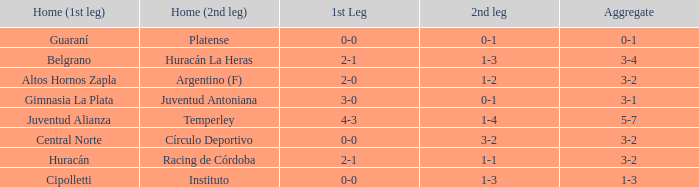Which team played their first leg at home with an aggregate score of 3-4? Belgrano. 